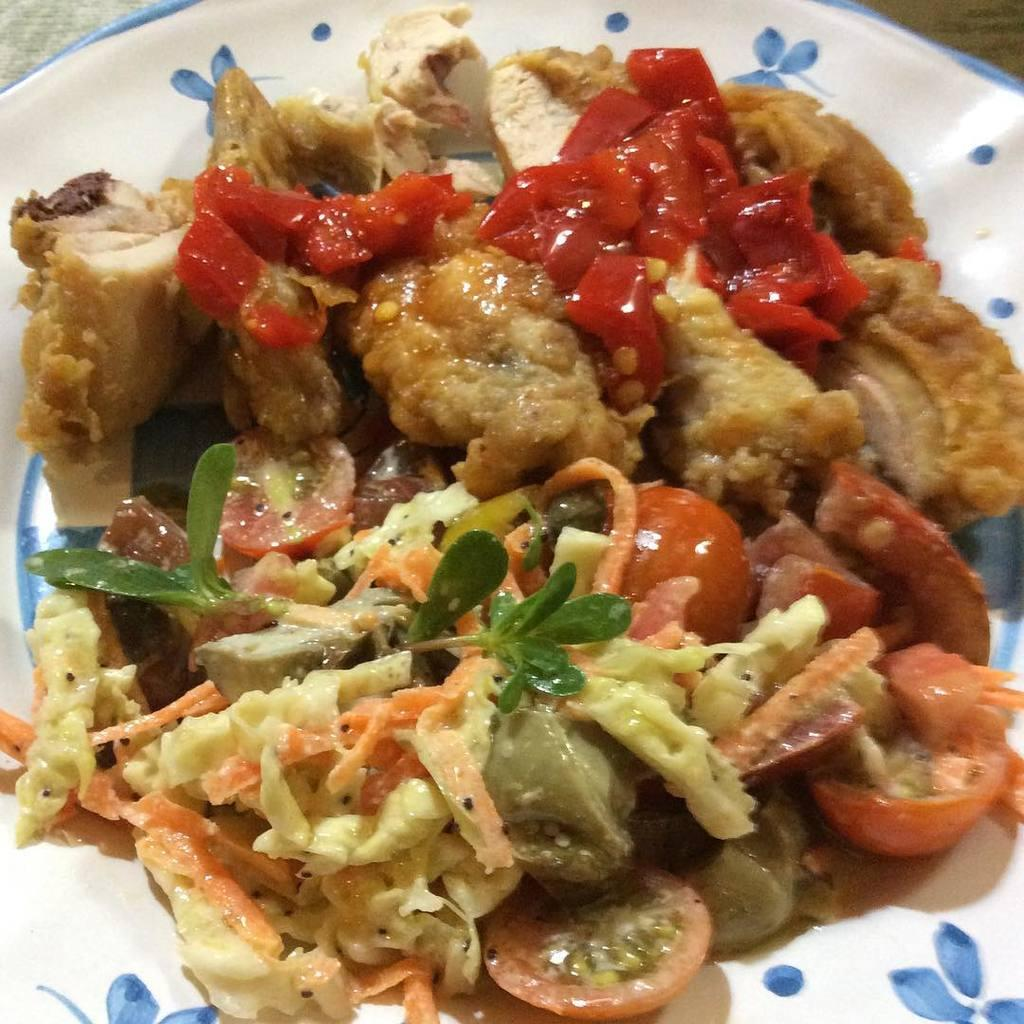What is on the plate that is visible in the image? There is a plate in the image, and it contains food. What type of food is on the plate? The food is made of meat. What other ingredients are present in the food? The food contains tomatoes and carrots. Are there any other ingredients in the food besides meat, tomatoes, and carrots? Yes, other ingredients are added to the food. What type of furniture is visible in the image? There is no furniture present in the image; it only shows a plate with food. How many stars can be seen in the image? There are no stars visible in the image. 